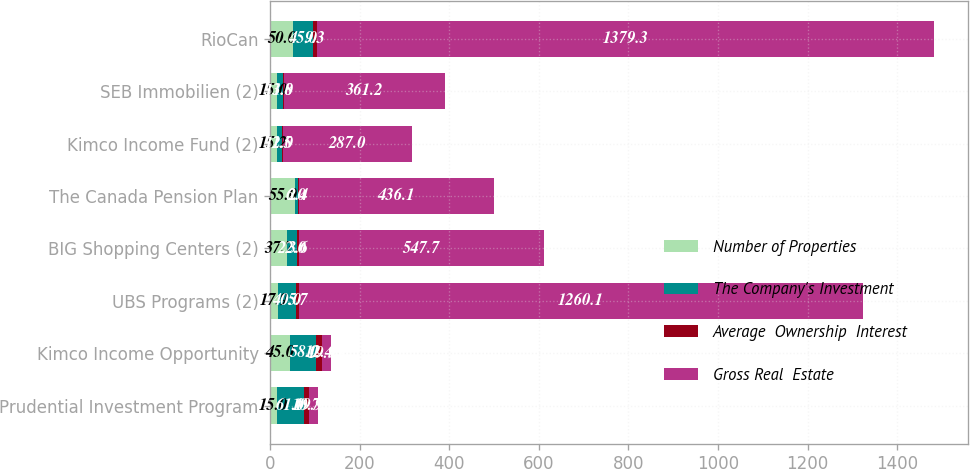Convert chart. <chart><loc_0><loc_0><loc_500><loc_500><stacked_bar_chart><ecel><fcel>Prudential Investment Program<fcel>Kimco Income Opportunity<fcel>UBS Programs (2)<fcel>BIG Shopping Centers (2)<fcel>The Canada Pension Plan<fcel>Kimco Income Fund (2)<fcel>SEB Immobilien (2)<fcel>RioCan<nl><fcel>Number of Properties<fcel>15<fcel>45<fcel>17.9<fcel>37.7<fcel>55<fcel>15.2<fcel>15<fcel>50<nl><fcel>The Company's Investment<fcel>61<fcel>58<fcel>40<fcel>22<fcel>6<fcel>12<fcel>13<fcel>45<nl><fcel>Average  Ownership  Interest<fcel>10.7<fcel>12.4<fcel>5.7<fcel>3.6<fcel>2.4<fcel>1.5<fcel>1.8<fcel>9.3<nl><fcel>Gross Real  Estate<fcel>19.95<fcel>19.95<fcel>1260.1<fcel>547.7<fcel>436.1<fcel>287<fcel>361.2<fcel>1379.3<nl></chart> 